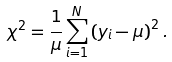<formula> <loc_0><loc_0><loc_500><loc_500>\chi ^ { 2 } = \frac { 1 } { \mu } \sum _ { i = 1 } ^ { N } \left ( y _ { i } - \mu \right ) ^ { 2 } .</formula> 